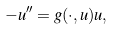Convert formula to latex. <formula><loc_0><loc_0><loc_500><loc_500>- u ^ { \prime \prime } = g ( \cdot , u ) u ,</formula> 